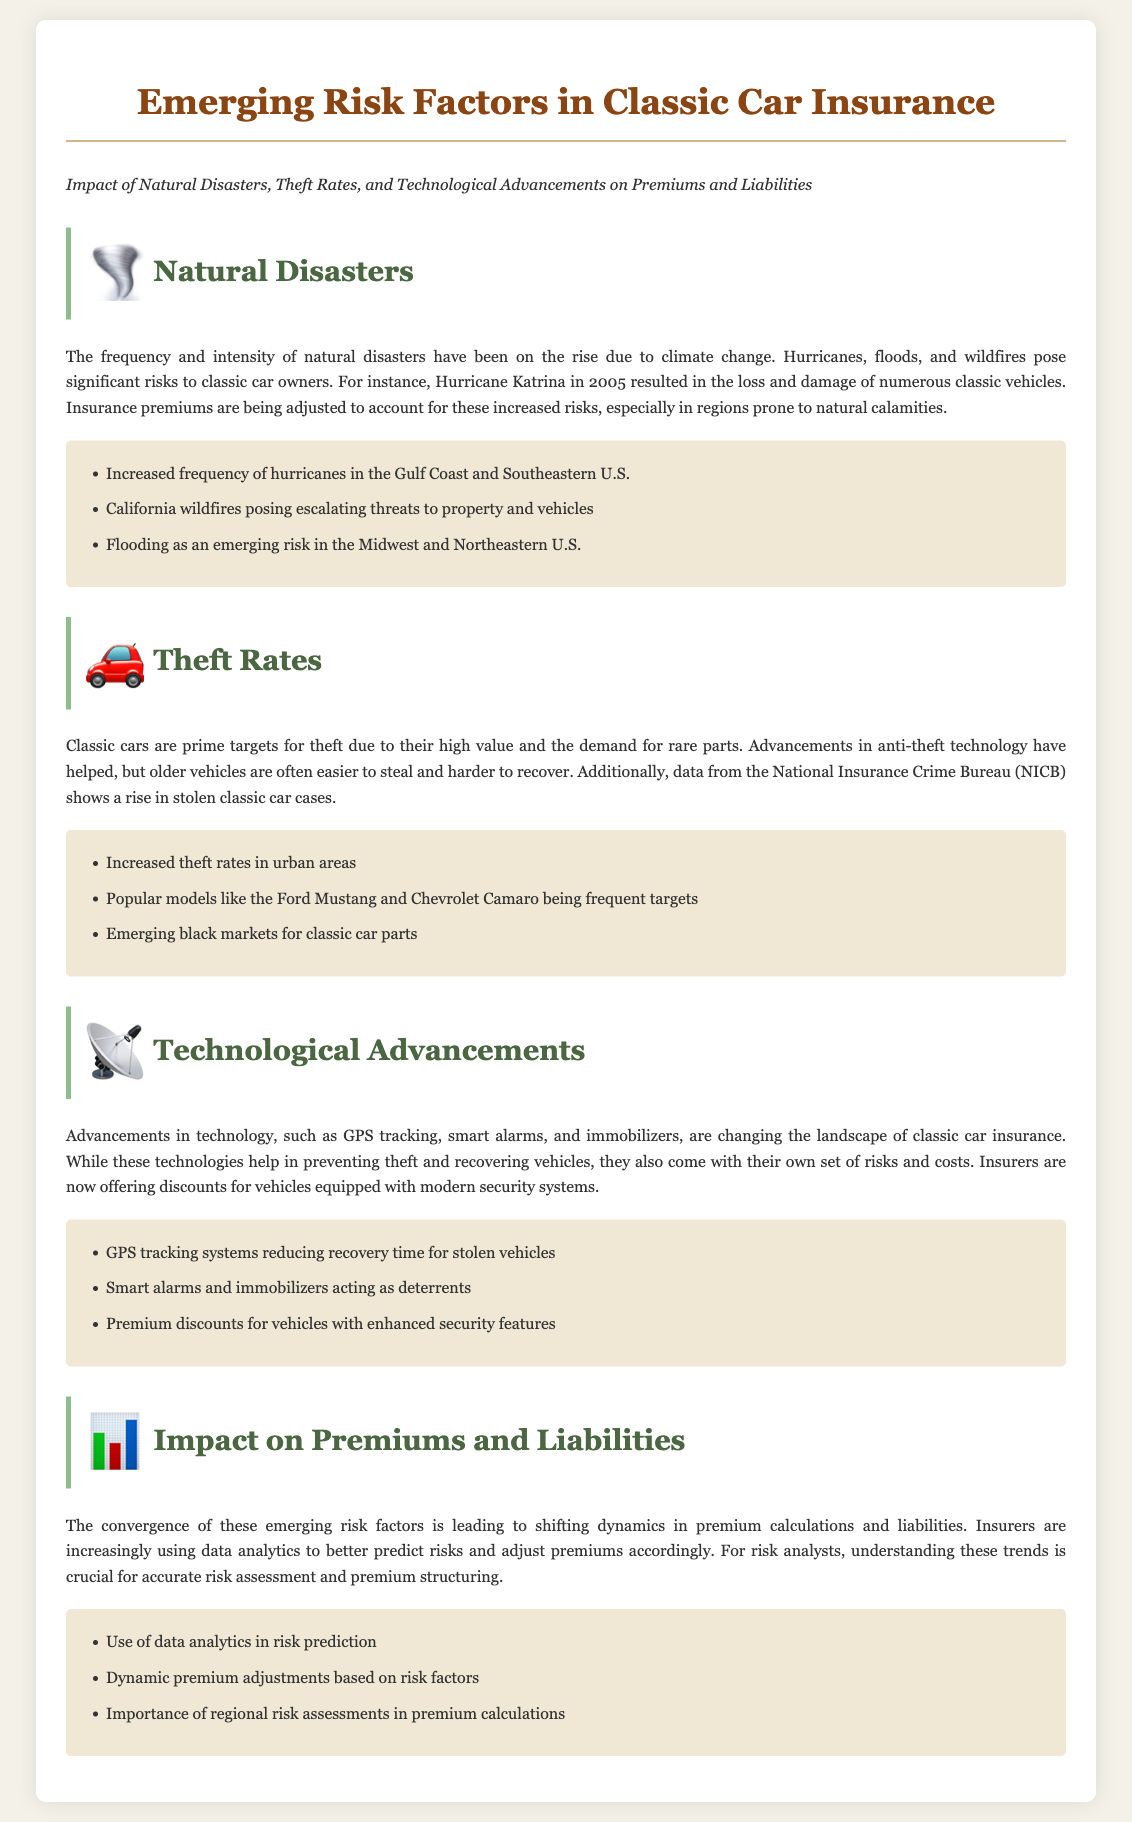What are some examples of natural disasters affecting classic cars? The document lists hurricanes, floods, and wildfires as examples.
Answer: hurricanes, floods, wildfires Which region is noted for increased hurricane activity? The Gulf Coast and Southeastern U.S. are mentioned.
Answer: Gulf Coast and Southeastern U.S What technology is mentioned as a tool for reducing recovery time? GPS tracking systems are highlighted for their effect on recovery.
Answer: GPS tracking systems What is a benefit of modern security features for classic cars? Premium discounts are offered for vehicles with enhanced security systems.
Answer: Premium discounts Which classic car models are frequently targeted for theft? The Ford Mustang and Chevrolet Camaro are cited as common targets.
Answer: Ford Mustang and Chevrolet Camaro How are insurers using data analytics in relation to classic car insurance? Insurers are using data analytics to better predict risks and adjust premiums.
Answer: Better predict risks and adjust premiums What new risk factor is included in the impact on premiums and liabilities? The convergence of emerging risk factors is affecting premium calculations.
Answer: Convergence of emerging risk factors Which area is mentioned as experiencing increased theft rates? Urban areas are indicated in the context of rising theft rates.
Answer: Urban areas What type of technology acts as a deterrent for classic car theft? Smart alarms and immobilizers are mentioned as deterrents.
Answer: Smart alarms and immobilizers 